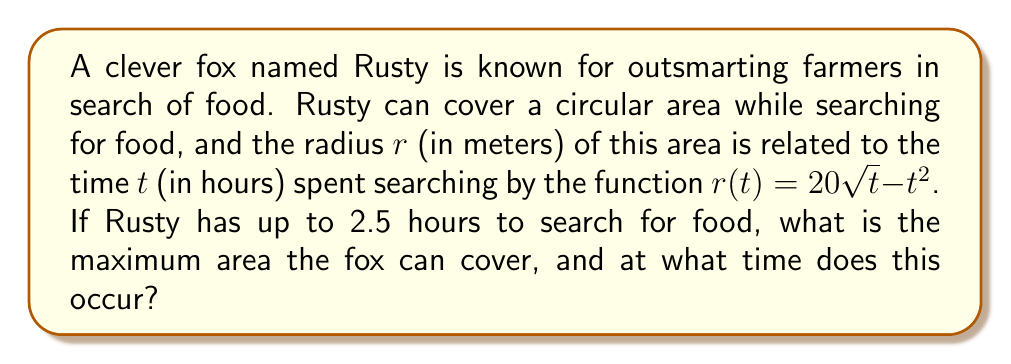Show me your answer to this math problem. To solve this problem, we need to follow these steps:

1) The area $A$ of a circle is given by $A = \pi r^2$. Substituting the given function for $r$, we get:

   $A(t) = \pi (20\sqrt{t} - t^2)^2$

2) To find the maximum area, we need to find the critical points of this function. We do this by taking the derivative and setting it equal to zero:

   $$\begin{align}
   A'(t) &= 2\pi (20\sqrt{t} - t^2) \cdot (10t^{-1/2} - 2t) \\
   &= 2\pi (20t^{1/2} - t^2) \cdot (10t^{-1/2} - 2t) \\
   &= 2\pi (200 - 20t^{3/2} - 10t^{1/2} + 2t^2)
   \end{align}$$

3) Setting $A'(t) = 0$:

   $200 - 20t^{3/2} - 10t^{1/2} + 2t^2 = 0$

4) This equation is difficult to solve algebraically, but we can solve it numerically. Using a graphing calculator or computer software, we find that this equation has a solution at $t \approx 1.25$ hours.

5) To confirm this is a maximum, we can check the second derivative is negative at this point (which it is).

6) Now that we know the time at which the maximum area occurs, we can calculate the maximum area:

   $r(1.25) = 20\sqrt{1.25} - (1.25)^2 = 20 \cdot 1.118 - 1.5625 = 20.8$

   $A_{max} = \pi (20.8)^2 \approx 1359.4$ square meters

Therefore, the maximum area Rusty can cover is approximately 1359.4 square meters, occurring at 1.25 hours into the search.
Answer: The maximum area Rusty can cover is approximately 1359.4 square meters, occurring at 1.25 hours into the search. 